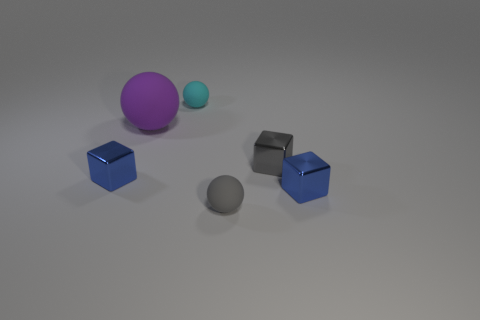Add 3 big cyan rubber cubes. How many objects exist? 9 Add 2 cyan objects. How many cyan objects exist? 3 Subtract 1 gray balls. How many objects are left? 5 Subtract all tiny red metallic balls. Subtract all blue metallic things. How many objects are left? 4 Add 3 blue metal things. How many blue metal things are left? 5 